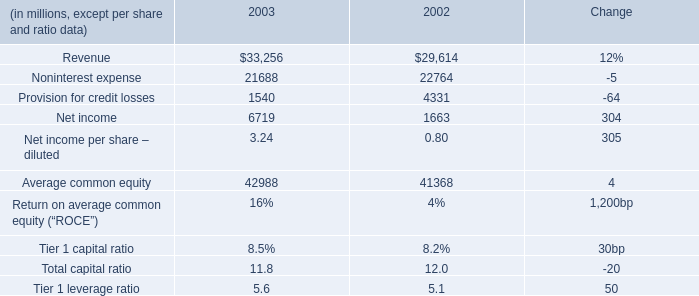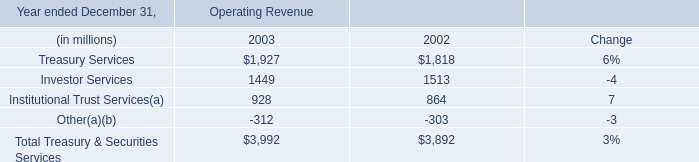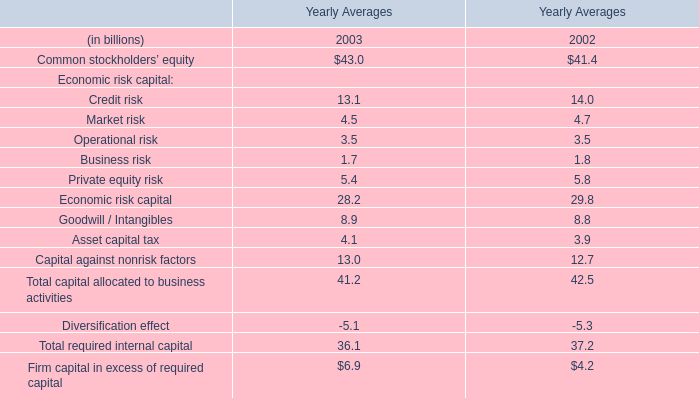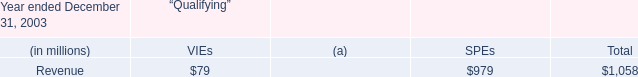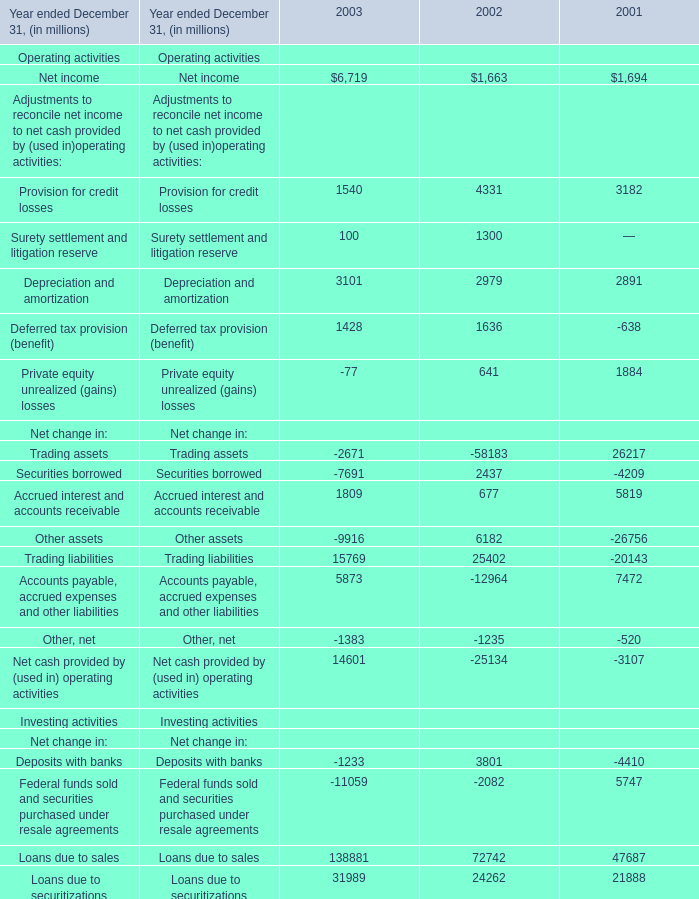What's the average of the Securities borrowed for Net change in in the years where Operational risk for Economic risk capital is positive? (in million) 
Computations: ((-7691 + 2437) / 2)
Answer: -2627.0. 